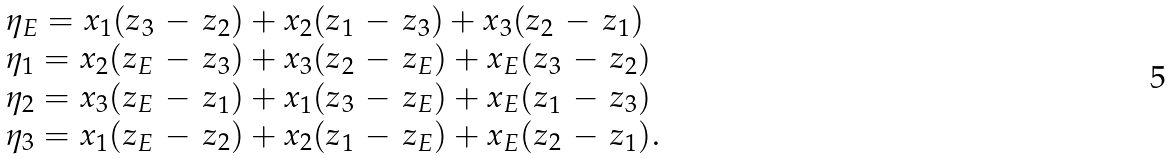<formula> <loc_0><loc_0><loc_500><loc_500>\begin{array} { l l } \eta _ { E } = x _ { 1 } ( z _ { 3 } \, - \, z _ { 2 } ) + x _ { 2 } ( z _ { 1 } \, - \, z _ { 3 } ) + x _ { 3 } ( z _ { 2 } \, - \, z _ { 1 } ) \\ \eta _ { 1 } = x _ { 2 } ( z _ { E } \, - \, z _ { 3 } ) + x _ { 3 } ( z _ { 2 } \, - \, z _ { E } ) + x _ { E } ( z _ { 3 } \, - \, z _ { 2 } ) \\ \eta _ { 2 } = x _ { 3 } ( z _ { E } \, - \, z _ { 1 } ) + x _ { 1 } ( z _ { 3 } \, - \, z _ { E } ) + x _ { E } ( z _ { 1 } \, - \, z _ { 3 } ) \\ \eta _ { 3 } = x _ { 1 } ( z _ { E } \, - \, z _ { 2 } ) + x _ { 2 } ( z _ { 1 } \, - \, z _ { E } ) + x _ { E } ( z _ { 2 } \, - \, z _ { 1 } ) . \end{array}</formula> 